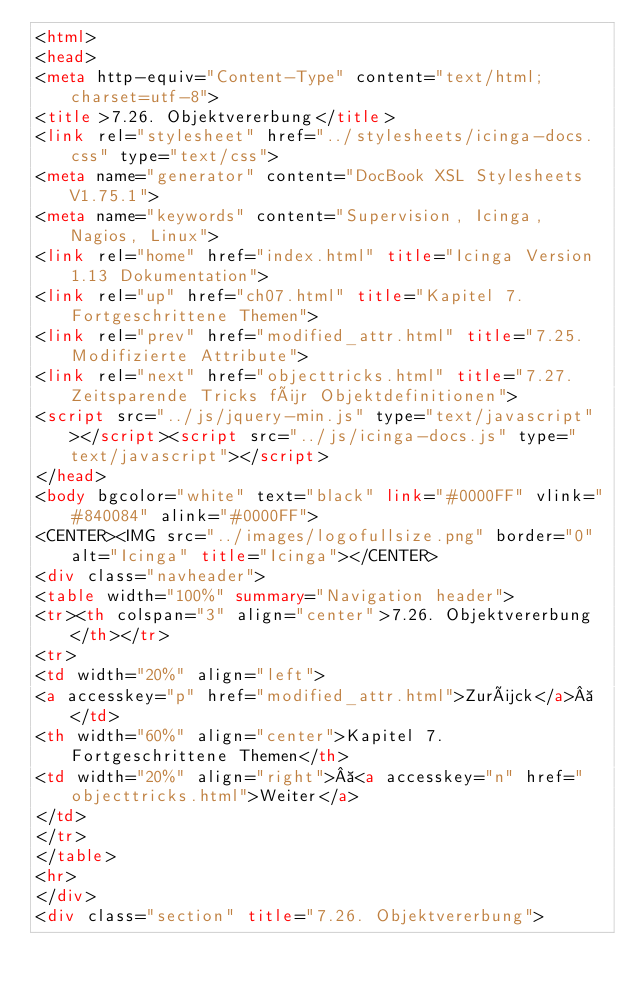<code> <loc_0><loc_0><loc_500><loc_500><_HTML_><html>
<head>
<meta http-equiv="Content-Type" content="text/html; charset=utf-8">
<title>7.26. Objektvererbung</title>
<link rel="stylesheet" href="../stylesheets/icinga-docs.css" type="text/css">
<meta name="generator" content="DocBook XSL Stylesheets V1.75.1">
<meta name="keywords" content="Supervision, Icinga, Nagios, Linux">
<link rel="home" href="index.html" title="Icinga Version 1.13 Dokumentation">
<link rel="up" href="ch07.html" title="Kapitel 7. Fortgeschrittene Themen">
<link rel="prev" href="modified_attr.html" title="7.25. Modifizierte Attribute">
<link rel="next" href="objecttricks.html" title="7.27. Zeitsparende Tricks für Objektdefinitionen">
<script src="../js/jquery-min.js" type="text/javascript"></script><script src="../js/icinga-docs.js" type="text/javascript"></script>
</head>
<body bgcolor="white" text="black" link="#0000FF" vlink="#840084" alink="#0000FF">
<CENTER><IMG src="../images/logofullsize.png" border="0" alt="Icinga" title="Icinga"></CENTER>
<div class="navheader">
<table width="100%" summary="Navigation header">
<tr><th colspan="3" align="center">7.26. Objektvererbung</th></tr>
<tr>
<td width="20%" align="left">
<a accesskey="p" href="modified_attr.html">Zurück</a> </td>
<th width="60%" align="center">Kapitel 7. Fortgeschrittene Themen</th>
<td width="20%" align="right"> <a accesskey="n" href="objecttricks.html">Weiter</a>
</td>
</tr>
</table>
<hr>
</div>
<div class="section" title="7.26. Objektvererbung"></code> 